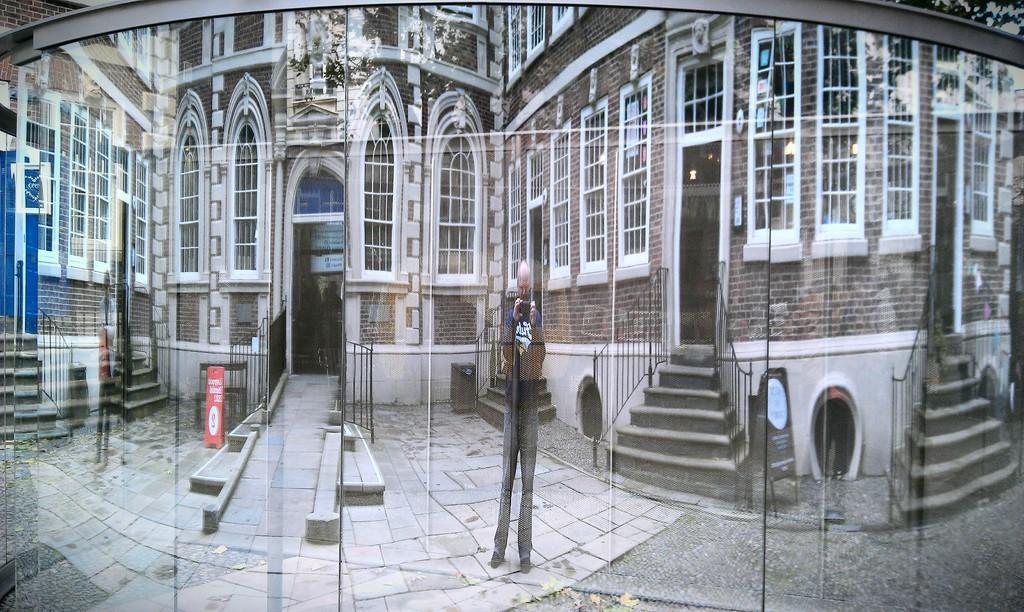How would you summarize this image in a sentence or two? A man is standing holding an object, this is a building and a door. 